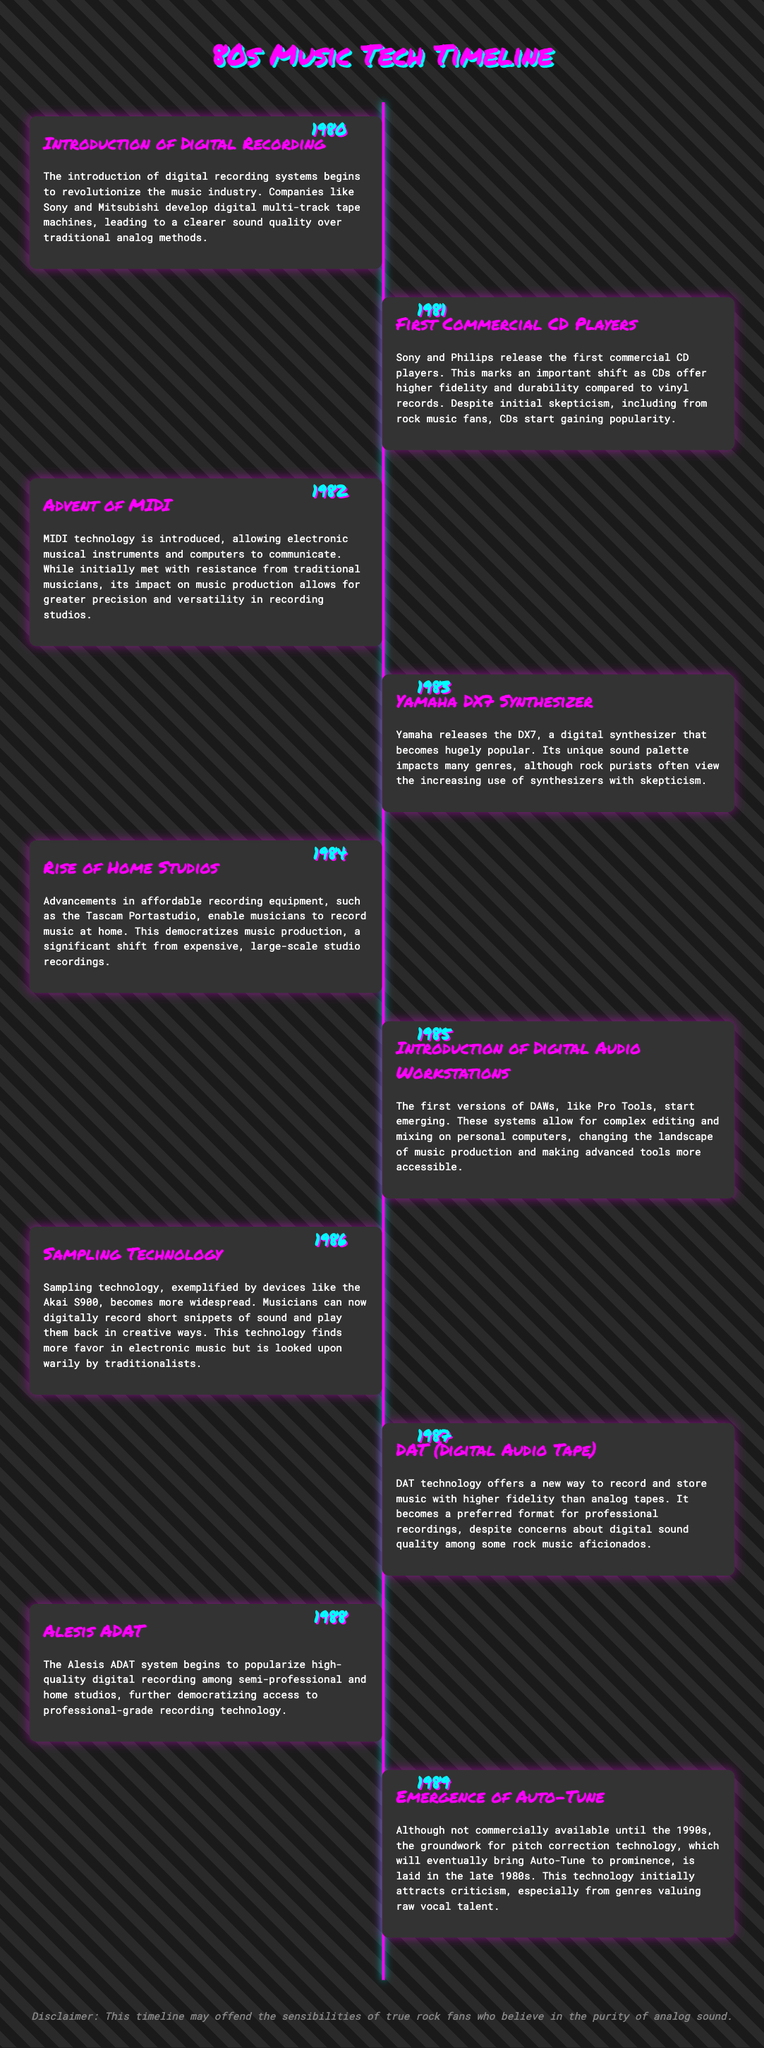what year did the introduction of digital recording occur? The document states that digital recording was introduced in 1980.
Answer: 1980 which company released the first commercial CD players? The timeline notes Sony and Philips as the companies that released the first commercial CD players.
Answer: Sony and Philips what technology was introduced in 1982? The document mentions that MIDI technology was introduced in 1982.
Answer: MIDI what synthesizer became popular in 1983? The timeline indicates that the Yamaha DX7 synthesizer became popular in 1983.
Answer: Yamaha DX7 how did advancements in recording equipment influence bedrooms in 1984? The timeline explains that affordable recording equipment led to the rise of home studios in 1984.
Answer: Home studios which technology began to widely use sampling in 1986? The document identifies the Akai S900 as the device associated with sampling technology in 1986.
Answer: Akai S900 what was the preferred format for professional recordings in 1987? The timeline notes that DAT (Digital Audio Tape) became the preferred format in 1987.
Answer: DAT what year did Alesis ADAT popularize high-quality digital recording? The document states that the Alesis ADAT system began popularizing high-quality digital recording in 1988.
Answer: 1988 which technology began to lay the groundwork for pitch correction in 1989? The timeline refers to the emergence of Auto-Tune technology in 1989.
Answer: Auto-Tune 